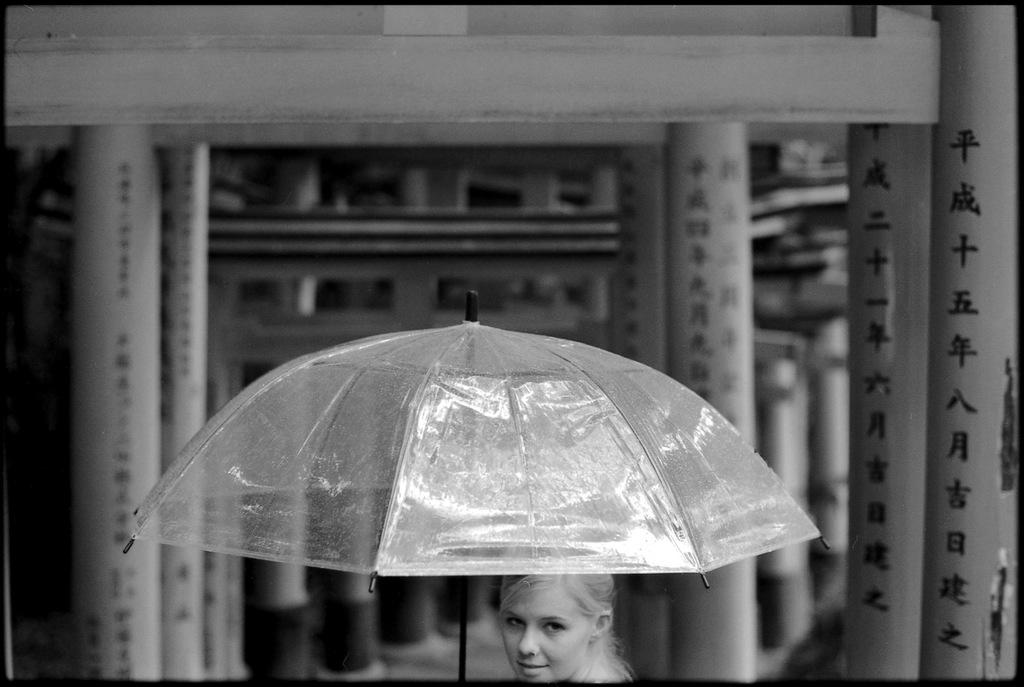What is the color scheme of the image? The image is black and white. Can you describe the person in the image? There is a person in the image, and they are holding an umbrella. What can be seen in the background of the image? There is a building in the background of the image. How many hooks are visible on the person's clothing in the image? There are no hooks visible on the person's clothing in the image; they are holding an umbrella. Are there any women present in the image? The provided facts do not mention the gender of the person in the image, so we cannot definitively answer whether there are any women present. 